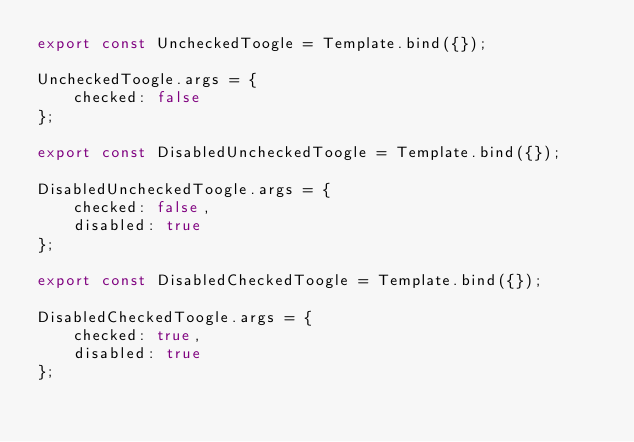Convert code to text. <code><loc_0><loc_0><loc_500><loc_500><_TypeScript_>export const UncheckedToogle = Template.bind({});

UncheckedToogle.args = {
    checked: false
};

export const DisabledUncheckedToogle = Template.bind({});

DisabledUncheckedToogle.args = {
    checked: false,
    disabled: true
};

export const DisabledCheckedToogle = Template.bind({});

DisabledCheckedToogle.args = {
    checked: true,
    disabled: true
};</code> 